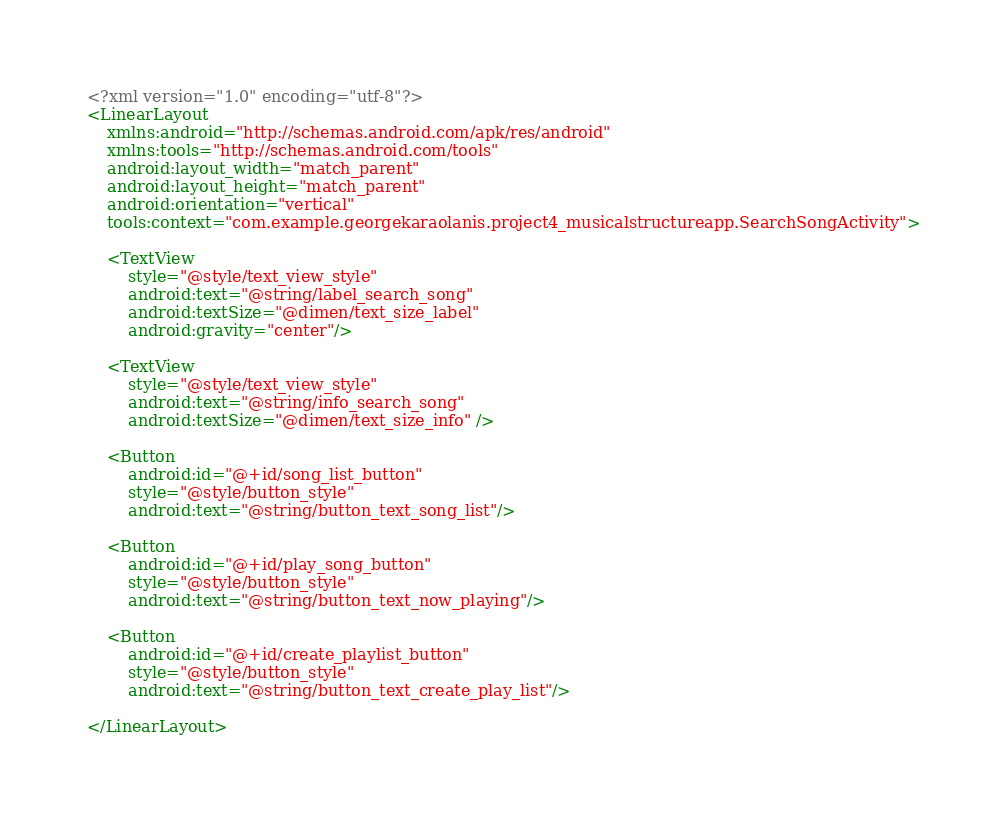Convert code to text. <code><loc_0><loc_0><loc_500><loc_500><_XML_><?xml version="1.0" encoding="utf-8"?>
<LinearLayout
    xmlns:android="http://schemas.android.com/apk/res/android"
    xmlns:tools="http://schemas.android.com/tools"
    android:layout_width="match_parent"
    android:layout_height="match_parent"
    android:orientation="vertical"
    tools:context="com.example.georgekaraolanis.project4_musicalstructureapp.SearchSongActivity">

    <TextView
        style="@style/text_view_style"
        android:text="@string/label_search_song"
        android:textSize="@dimen/text_size_label"
        android:gravity="center"/>

    <TextView
        style="@style/text_view_style"
        android:text="@string/info_search_song"
        android:textSize="@dimen/text_size_info" />

    <Button
        android:id="@+id/song_list_button"
        style="@style/button_style"
        android:text="@string/button_text_song_list"/>

    <Button
        android:id="@+id/play_song_button"
        style="@style/button_style"
        android:text="@string/button_text_now_playing"/>

    <Button
        android:id="@+id/create_playlist_button"
        style="@style/button_style"
        android:text="@string/button_text_create_play_list"/>

</LinearLayout>
</code> 